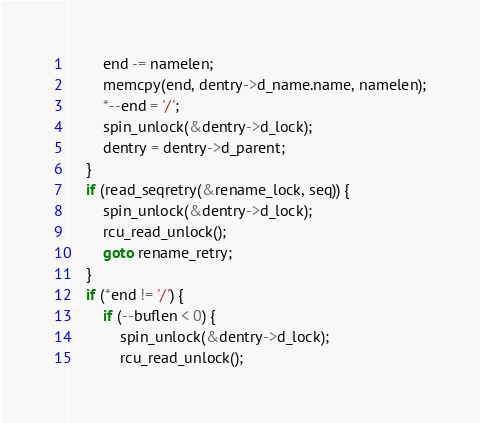<code> <loc_0><loc_0><loc_500><loc_500><_C_>		end -= namelen;
		memcpy(end, dentry->d_name.name, namelen);
		*--end = '/';
		spin_unlock(&dentry->d_lock);
		dentry = dentry->d_parent;
	}
	if (read_seqretry(&rename_lock, seq)) {
		spin_unlock(&dentry->d_lock);
		rcu_read_unlock();
		goto rename_retry;
	}
	if (*end != '/') {
		if (--buflen < 0) {
			spin_unlock(&dentry->d_lock);
			rcu_read_unlock();</code> 